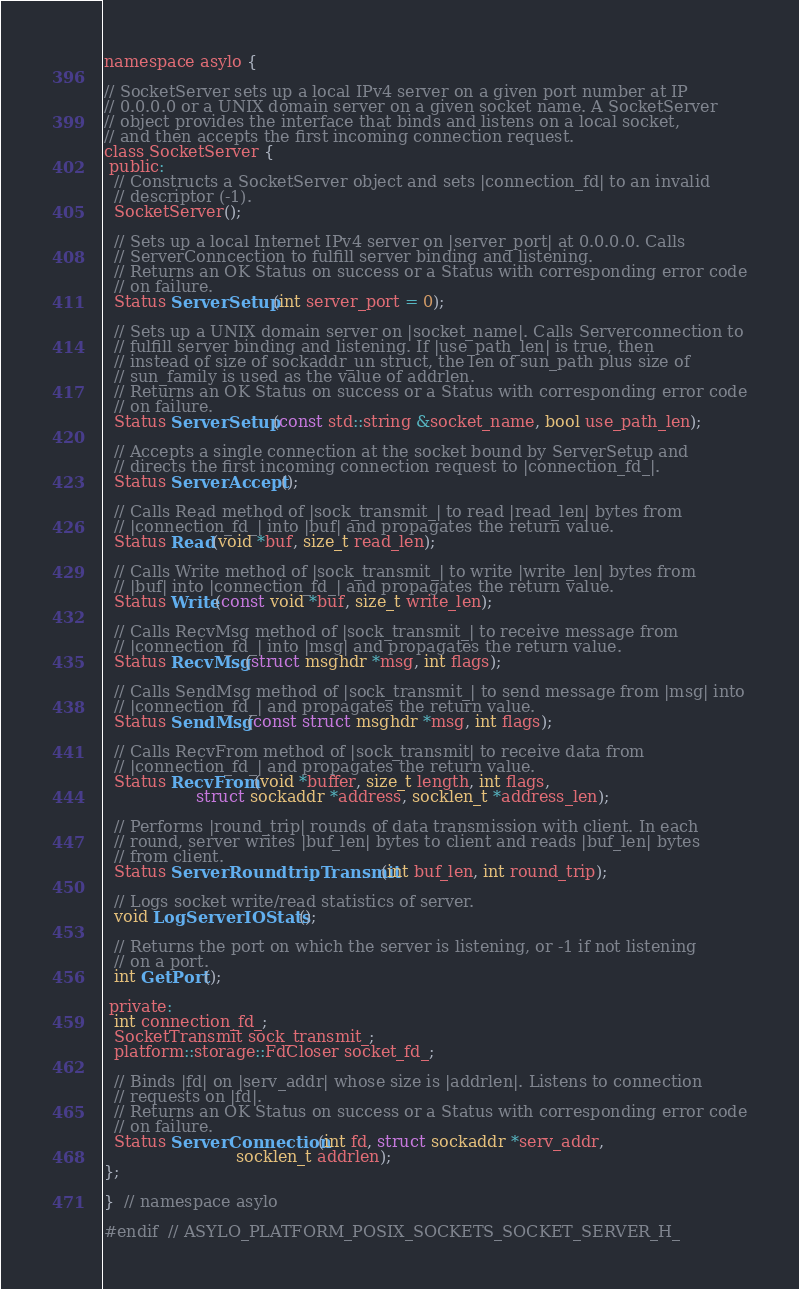Convert code to text. <code><loc_0><loc_0><loc_500><loc_500><_C_>
namespace asylo {

// SocketServer sets up a local IPv4 server on a given port number at IP
// 0.0.0.0 or a UNIX domain server on a given socket name. A SocketServer
// object provides the interface that binds and listens on a local socket,
// and then accepts the first incoming connection request.
class SocketServer {
 public:
  // Constructs a SocketServer object and sets |connection_fd| to an invalid
  // descriptor (-1).
  SocketServer();

  // Sets up a local Internet IPv4 server on |server_port| at 0.0.0.0. Calls
  // ServerConncection to fulfill server binding and listening.
  // Returns an OK Status on success or a Status with corresponding error code
  // on failure.
  Status ServerSetup(int server_port = 0);

  // Sets up a UNIX domain server on |socket_name|. Calls Serverconnection to
  // fulfill server binding and listening. If |use_path_len| is true, then
  // instead of size of sockaddr_un struct, the len of sun_path plus size of
  // sun_family is used as the value of addrlen.
  // Returns an OK Status on success or a Status with corresponding error code
  // on failure.
  Status ServerSetup(const std::string &socket_name, bool use_path_len);

  // Accepts a single connection at the socket bound by ServerSetup and
  // directs the first incoming connection request to |connection_fd_|.
  Status ServerAccept();

  // Calls Read method of |sock_transmit_| to read |read_len| bytes from
  // |connection_fd_| into |buf| and propagates the return value.
  Status Read(void *buf, size_t read_len);

  // Calls Write method of |sock_transmit_| to write |write_len| bytes from
  // |buf| into |connection_fd_| and propagates the return value.
  Status Write(const void *buf, size_t write_len);

  // Calls RecvMsg method of |sock_transmit_| to receive message from
  // |connection_fd_| into |msg| and propagates the return value.
  Status RecvMsg(struct msghdr *msg, int flags);

  // Calls SendMsg method of |sock_transmit_| to send message from |msg| into
  // |connection_fd_| and propagates the return value.
  Status SendMsg(const struct msghdr *msg, int flags);

  // Calls RecvFrom method of |sock_transmit| to receive data from
  // |connection_fd_| and propagates the return value.
  Status RecvFrom(void *buffer, size_t length, int flags,
                  struct sockaddr *address, socklen_t *address_len);

  // Performs |round_trip| rounds of data transmission with client. In each
  // round, server writes |buf_len| bytes to client and reads |buf_len| bytes
  // from client.
  Status ServerRoundtripTransmit(int buf_len, int round_trip);

  // Logs socket write/read statistics of server.
  void LogServerIOStats();

  // Returns the port on which the server is listening, or -1 if not listening
  // on a port.
  int GetPort();

 private:
  int connection_fd_;
  SocketTransmit sock_transmit_;
  platform::storage::FdCloser socket_fd_;

  // Binds |fd| on |serv_addr| whose size is |addrlen|. Listens to connection
  // requests on |fd|.
  // Returns an OK Status on success or a Status with corresponding error code
  // on failure.
  Status ServerConnection(int fd, struct sockaddr *serv_addr,
                          socklen_t addrlen);
};

}  // namespace asylo

#endif  // ASYLO_PLATFORM_POSIX_SOCKETS_SOCKET_SERVER_H_
</code> 